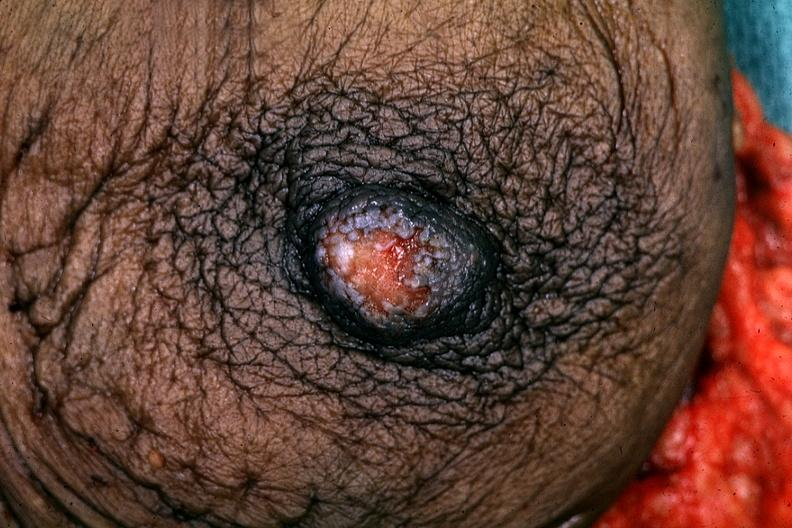what is present?
Answer the question using a single word or phrase. Pagets disease 